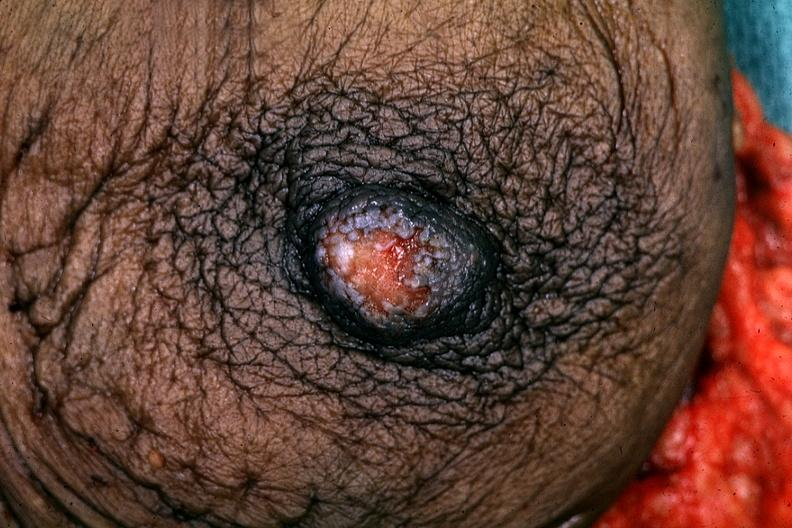what is present?
Answer the question using a single word or phrase. Pagets disease 